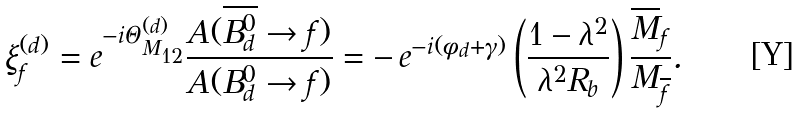<formula> <loc_0><loc_0><loc_500><loc_500>\xi _ { f } ^ { ( d ) } = e ^ { - i \Theta _ { M _ { 1 2 } } ^ { ( d ) } } \frac { A ( \overline { B ^ { 0 } _ { d } } \to f ) } { A ( B ^ { 0 } _ { d } \to f ) } = - \, e ^ { - i ( \phi _ { d } + \gamma ) } \left ( \frac { 1 - \lambda ^ { 2 } } { \lambda ^ { 2 } R _ { b } } \right ) \frac { \overline { M } _ { f } } { M _ { \overline { f } } } .</formula> 